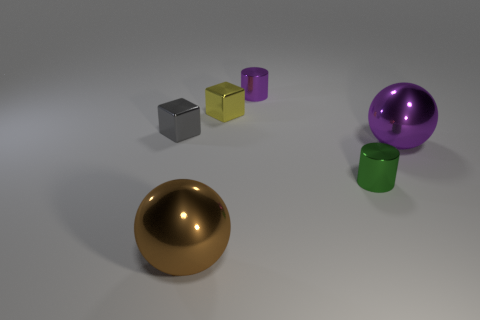What number of other things are there of the same material as the small green cylinder
Your answer should be compact. 5. Are the large thing that is on the right side of the small purple shiny thing and the tiny green thing made of the same material?
Provide a succinct answer. Yes. What is the shape of the gray object?
Provide a succinct answer. Cube. Are there more purple objects on the left side of the big brown metal object than brown things?
Your answer should be very brief. No. Is there anything else that has the same shape as the brown metallic thing?
Give a very brief answer. Yes. There is another tiny metal object that is the same shape as the tiny purple object; what color is it?
Your answer should be compact. Green. There is a large metal thing that is to the left of the green shiny thing; what shape is it?
Your answer should be compact. Sphere. There is a tiny gray thing; are there any small yellow metallic objects in front of it?
Offer a very short reply. No. Is there anything else that is the same size as the yellow object?
Offer a terse response. Yes. What color is the other large ball that is made of the same material as the large brown ball?
Keep it short and to the point. Purple. 